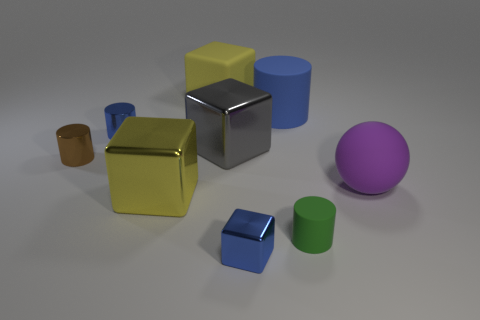Subtract 1 cylinders. How many cylinders are left? 3 Add 1 big cylinders. How many objects exist? 10 Subtract all cubes. How many objects are left? 5 Add 9 blue metallic cylinders. How many blue metallic cylinders are left? 10 Add 2 blue cylinders. How many blue cylinders exist? 4 Subtract 0 brown balls. How many objects are left? 9 Subtract all gray spheres. Subtract all blue cubes. How many objects are left? 8 